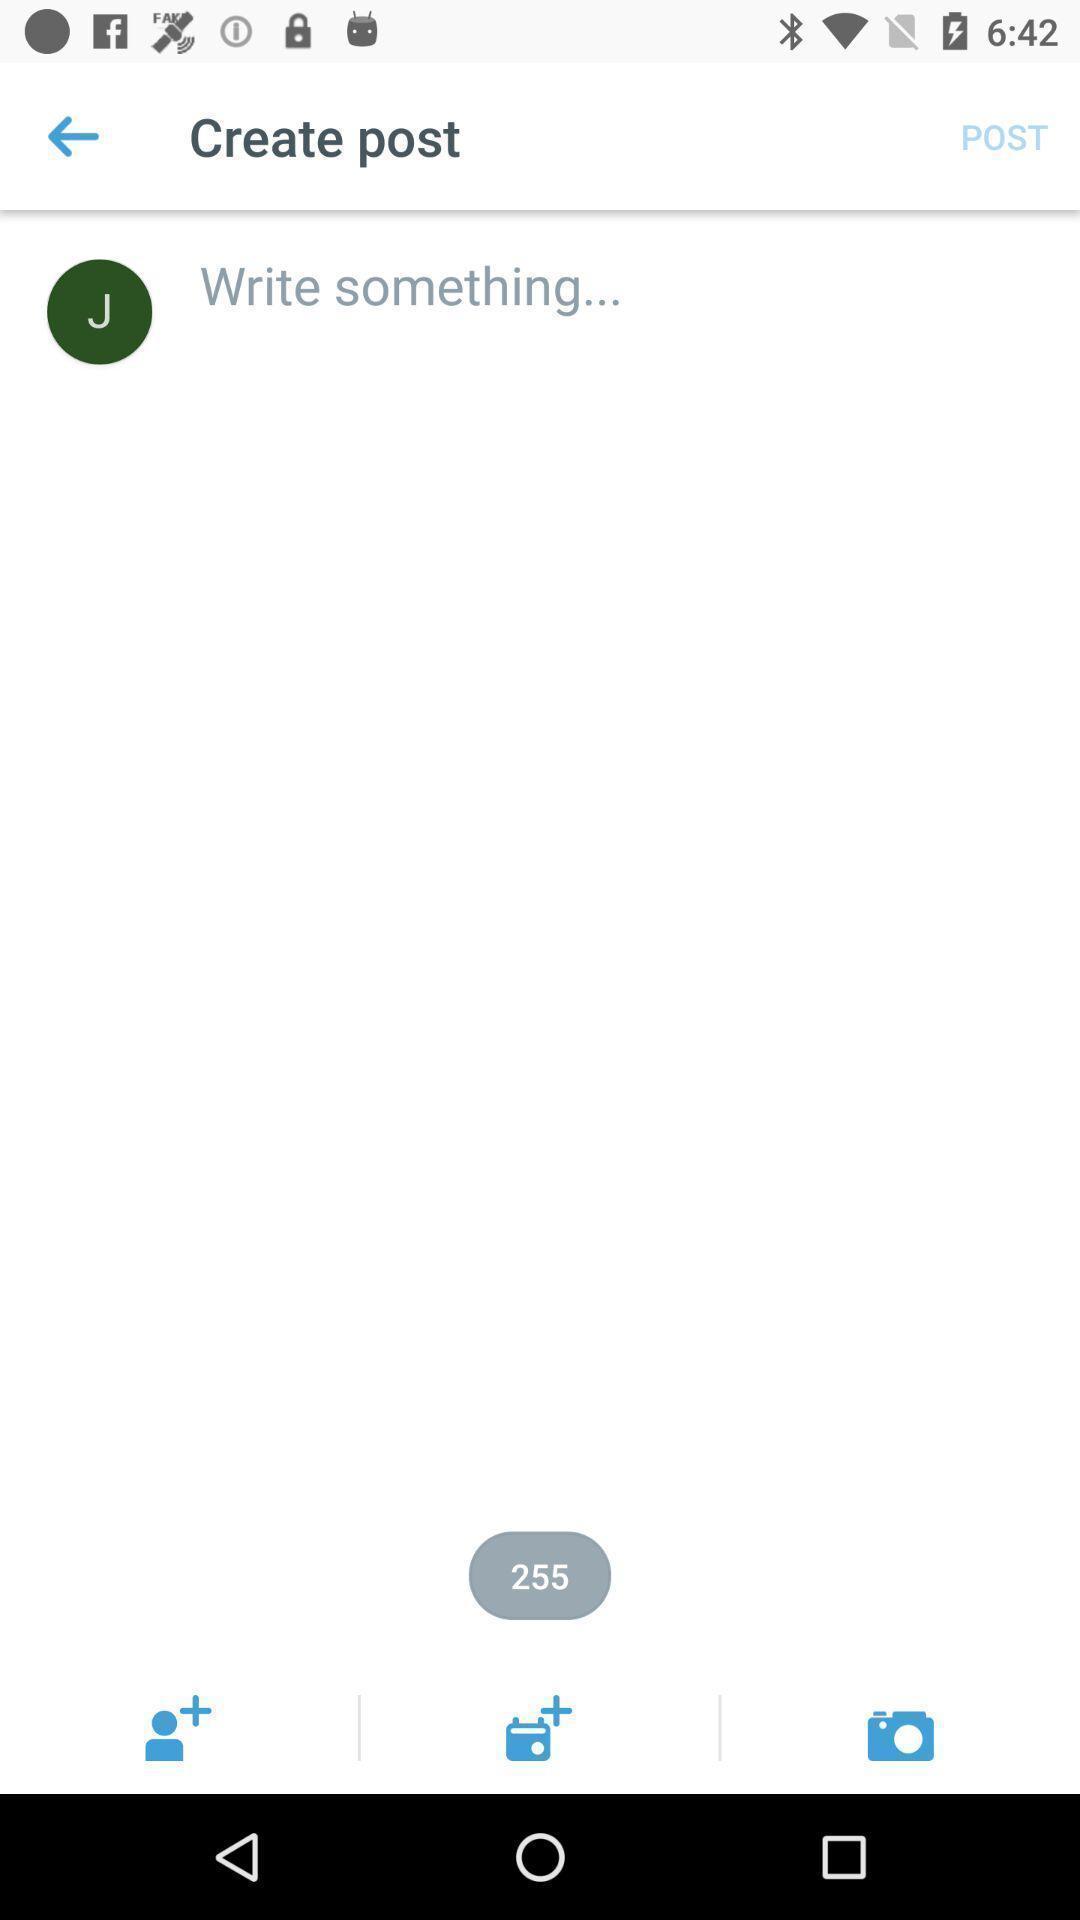What details can you identify in this image? Page displaying writing a post. 